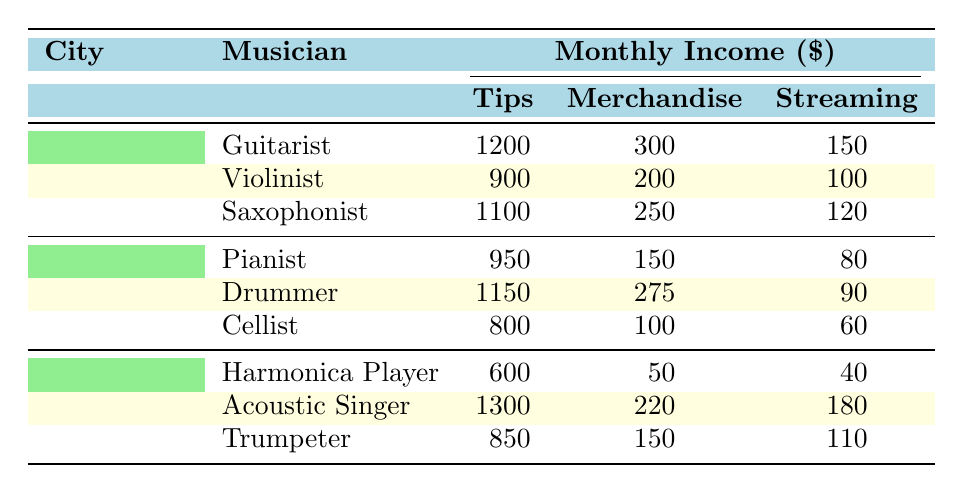What is the total monthly income of the Acoustic Singer? The monthly income of the Acoustic Singer consists of three components: Tips (1300), Merchandise Sales (220), and Online Streaming (180). Summing these values gives us: 1300 + 220 + 180 = 1700.
Answer: 1700 Which musician in Los Angeles earns the most from tips? In Los Angeles, we have three musicians: Pianist (950), Drummer (1150), and Cellist (800). The highest tip amount is from the Drummer with 1150.
Answer: Drummer What is the average income from merchandise sales of musicians in New York? In New York, the merchandise sales are: Guitarist (300), Violinist (200), and Saxophonist (250). First, we calculate the total: 300 + 200 + 250 = 750. There are three musicians, so the average is 750 / 3 = 250.
Answer: 250 Does any musician in Chicago earn more from online streaming than the Harmonica Player? The Harmonica Player earns 40 from online streaming. The other musicians in Chicago earn: Acoustic Singer (180) and Trumpeter (110). Comparing all, Acoustic Singer (180) earns more than Harmonica Player (40).
Answer: Yes What is the total monthly income for all musicians in Los Angeles? The monthly incomes for Los Angeles are: Pianist (950), Drummer (1150), and Cellist (800). Summing these gives us: 950 + 1150 + 800 = 2900.
Answer: 2900 